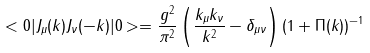Convert formula to latex. <formula><loc_0><loc_0><loc_500><loc_500>< 0 | J _ { \mu } ( k ) J _ { \nu } ( - k ) | 0 > = \frac { g ^ { 2 } } { \pi ^ { 2 } } \left ( \frac { k _ { \mu } k _ { \nu } } { k ^ { 2 } } - \delta _ { \mu \nu } \right ) \left ( 1 + \Pi ( k ) \right ) ^ { - 1 }</formula> 